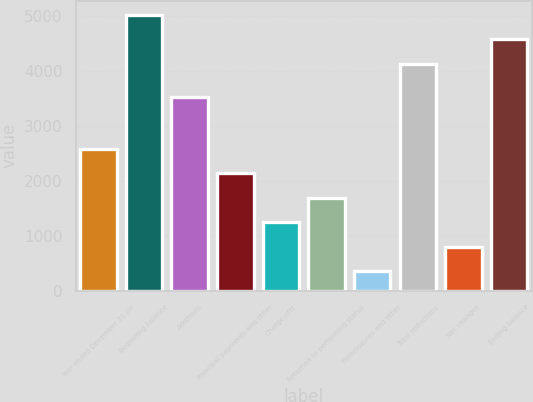Convert chart. <chart><loc_0><loc_0><loc_500><loc_500><bar_chart><fcel>Year ended December 31 (in<fcel>Beginning balance<fcel>Additions<fcel>Principal payments and other<fcel>Charge-offs<fcel>Returned to performing status<fcel>Foreclosures and other<fcel>Total reductions<fcel>Net changes<fcel>Ending balance<nl><fcel>2585.5<fcel>5029.8<fcel>3525<fcel>2138.6<fcel>1244.8<fcel>1691.7<fcel>351<fcel>4136<fcel>797.9<fcel>4582.9<nl></chart> 